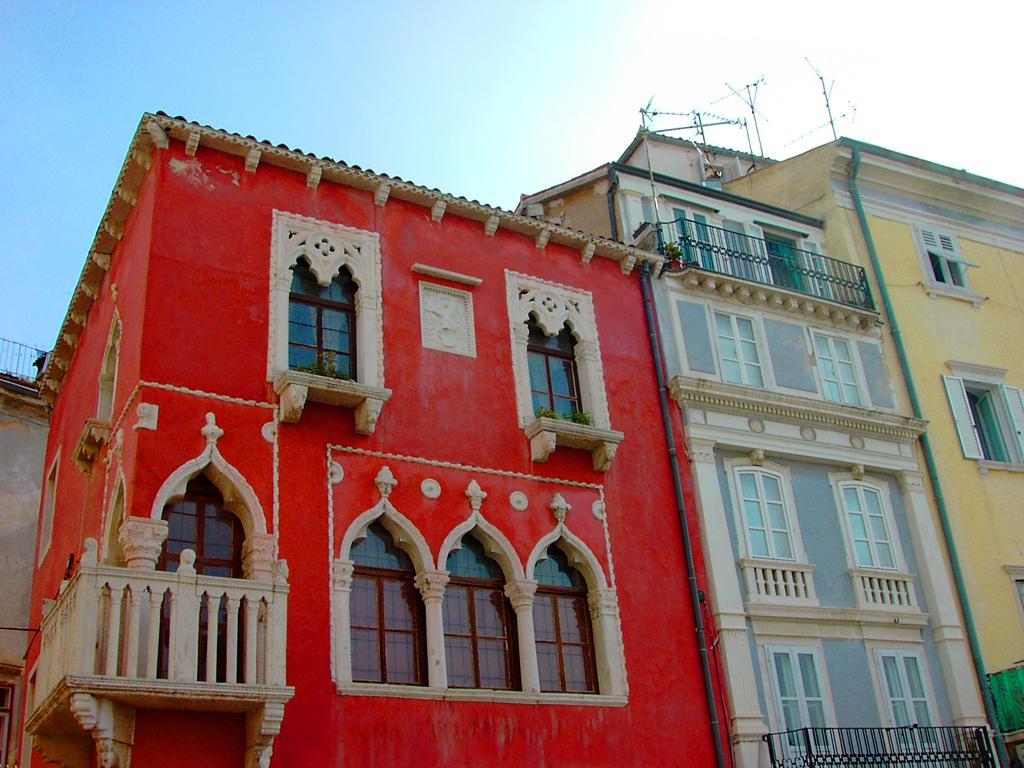What is the color of the sky in the image? The sky is clear and blue in the image. What type of weather can be inferred from the sky? It appears to be a sunny day in the image. What structure is present in the image? There is a building in the image. What feature of the building is mentioned in the facts? The building has windows. What colors are used to paint the walls of the building? The walls of the building are painted with red and yellow paints. What type of creature can be seen visiting the building in the image? There is no creature or visitor present in the image; it only features a building with painted walls and windows. 